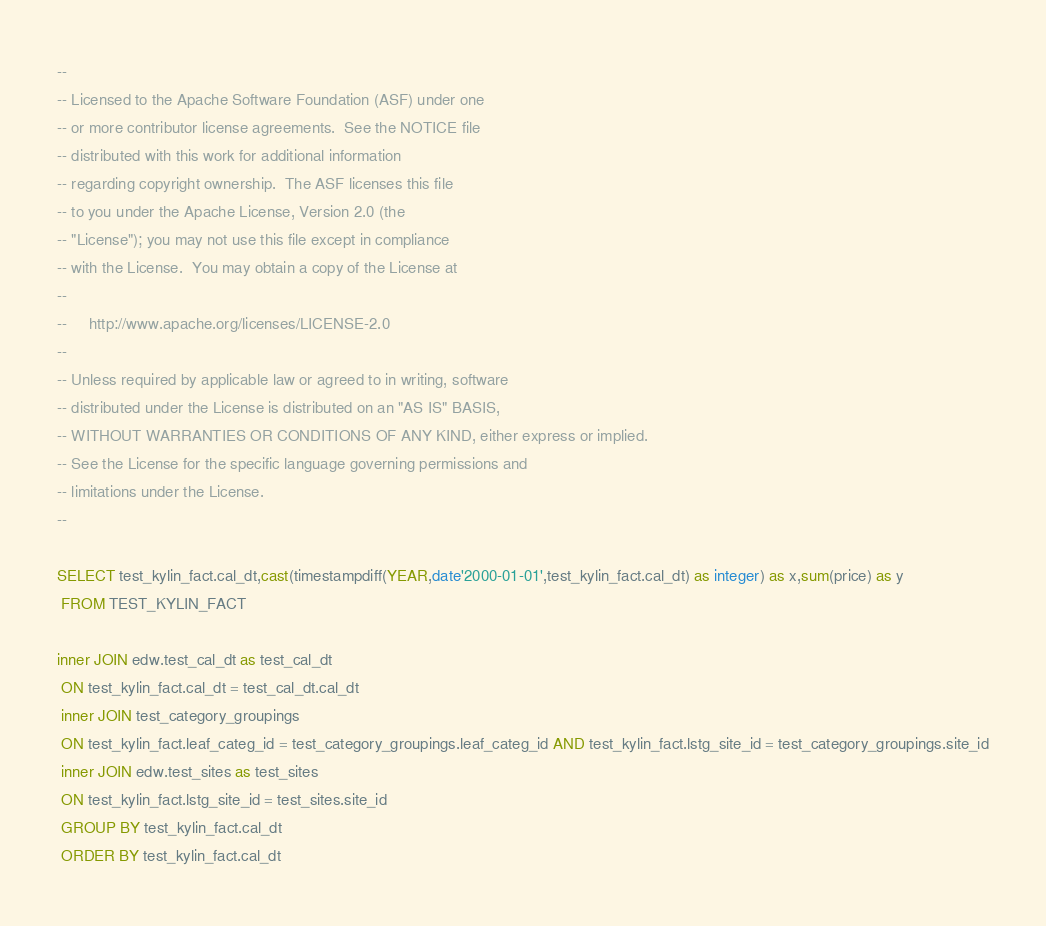Convert code to text. <code><loc_0><loc_0><loc_500><loc_500><_SQL_>--
-- Licensed to the Apache Software Foundation (ASF) under one
-- or more contributor license agreements.  See the NOTICE file
-- distributed with this work for additional information
-- regarding copyright ownership.  The ASF licenses this file
-- to you under the Apache License, Version 2.0 (the
-- "License"); you may not use this file except in compliance
-- with the License.  You may obtain a copy of the License at
--
--     http://www.apache.org/licenses/LICENSE-2.0
--
-- Unless required by applicable law or agreed to in writing, software
-- distributed under the License is distributed on an "AS IS" BASIS,
-- WITHOUT WARRANTIES OR CONDITIONS OF ANY KIND, either express or implied.
-- See the License for the specific language governing permissions and
-- limitations under the License.
--

SELECT test_kylin_fact.cal_dt,cast(timestampdiff(YEAR,date'2000-01-01',test_kylin_fact.cal_dt) as integer) as x,sum(price) as y
 FROM TEST_KYLIN_FACT 
 
inner JOIN edw.test_cal_dt as test_cal_dt
 ON test_kylin_fact.cal_dt = test_cal_dt.cal_dt
 inner JOIN test_category_groupings
 ON test_kylin_fact.leaf_categ_id = test_category_groupings.leaf_categ_id AND test_kylin_fact.lstg_site_id = test_category_groupings.site_id
 inner JOIN edw.test_sites as test_sites
 ON test_kylin_fact.lstg_site_id = test_sites.site_id
 GROUP BY test_kylin_fact.cal_dt
 ORDER BY test_kylin_fact.cal_dt</code> 